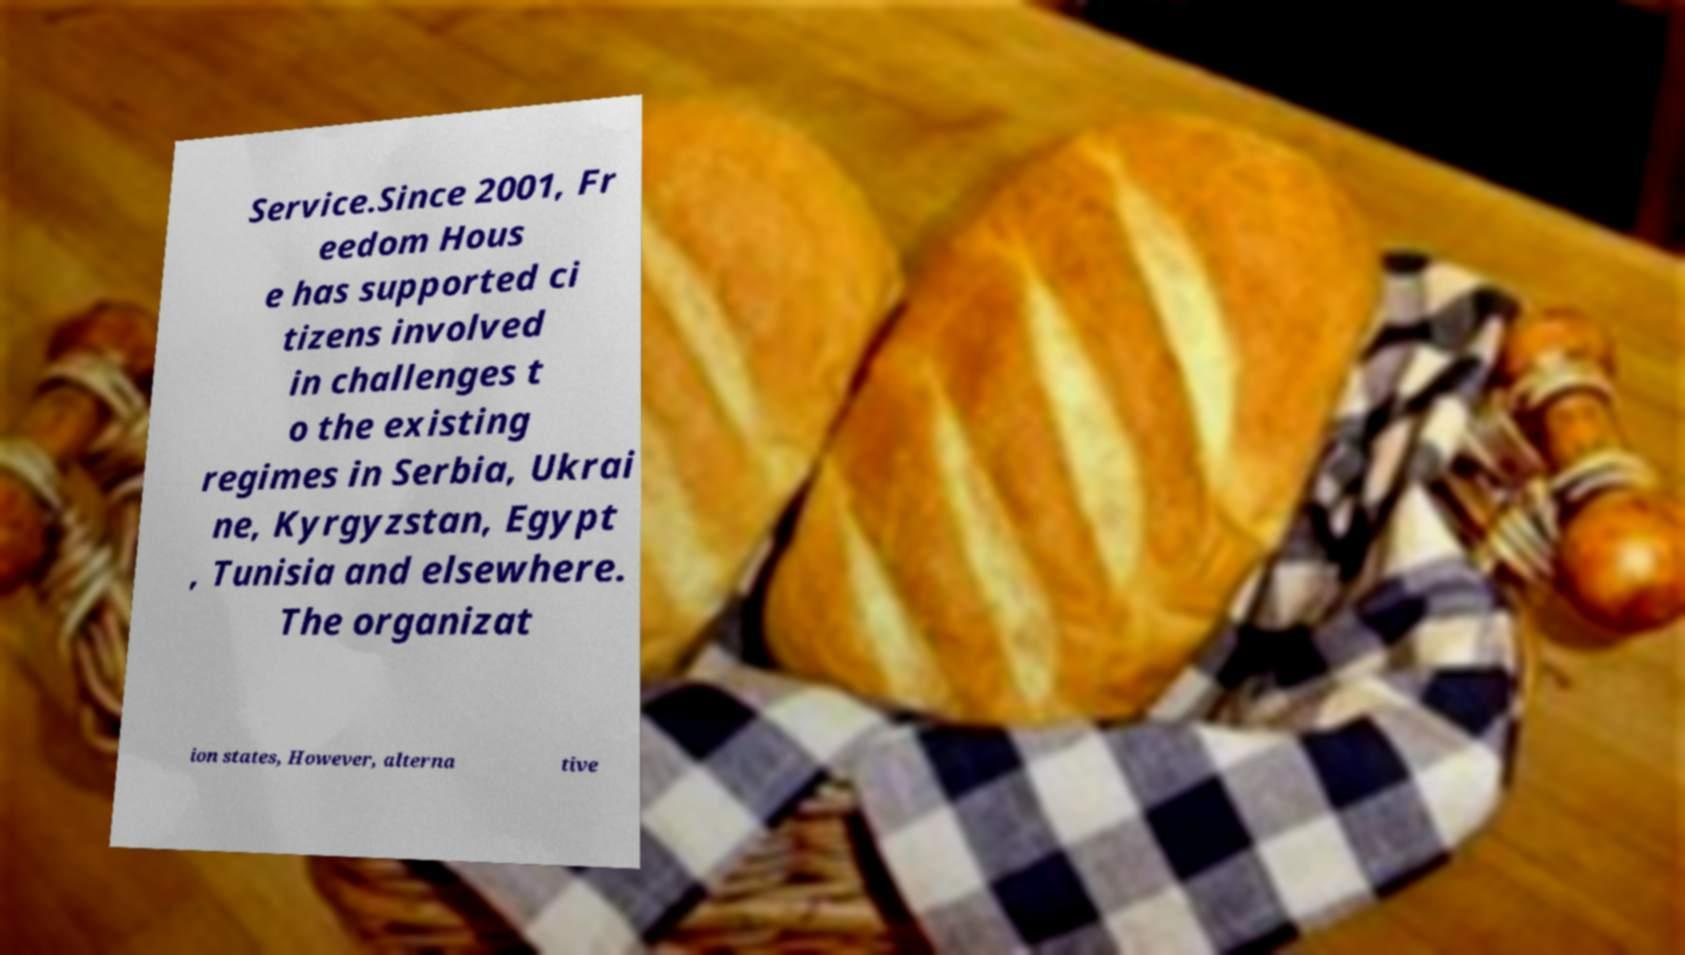Can you read and provide the text displayed in the image?This photo seems to have some interesting text. Can you extract and type it out for me? Service.Since 2001, Fr eedom Hous e has supported ci tizens involved in challenges t o the existing regimes in Serbia, Ukrai ne, Kyrgyzstan, Egypt , Tunisia and elsewhere. The organizat ion states, However, alterna tive 